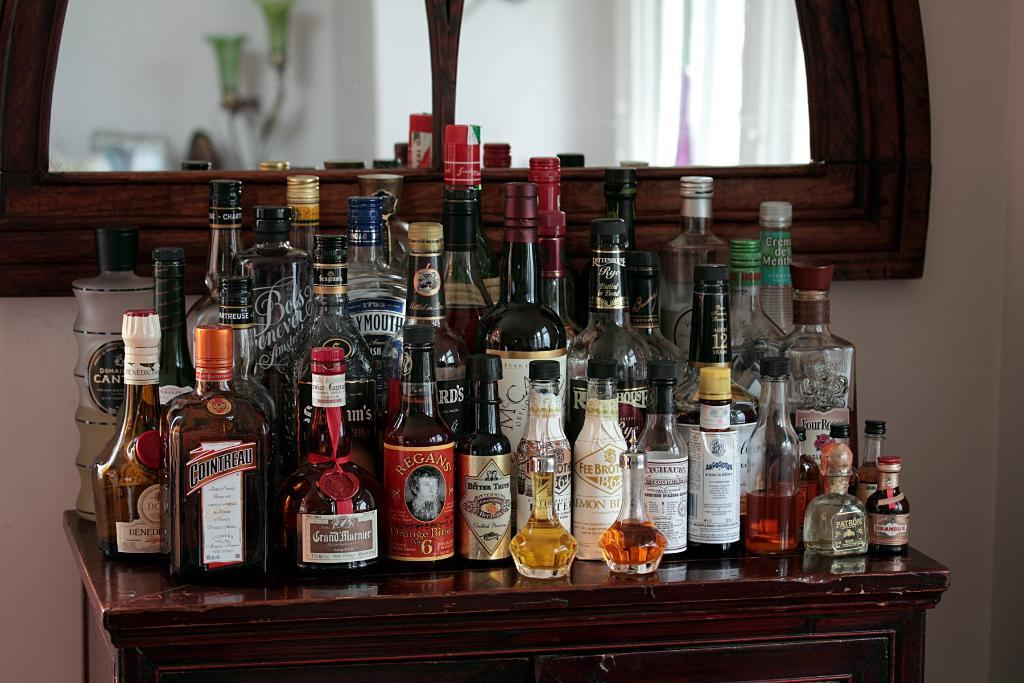<image>
Share a concise interpretation of the image provided. A tabletop of alcohol including a bottle of Cointreau. 